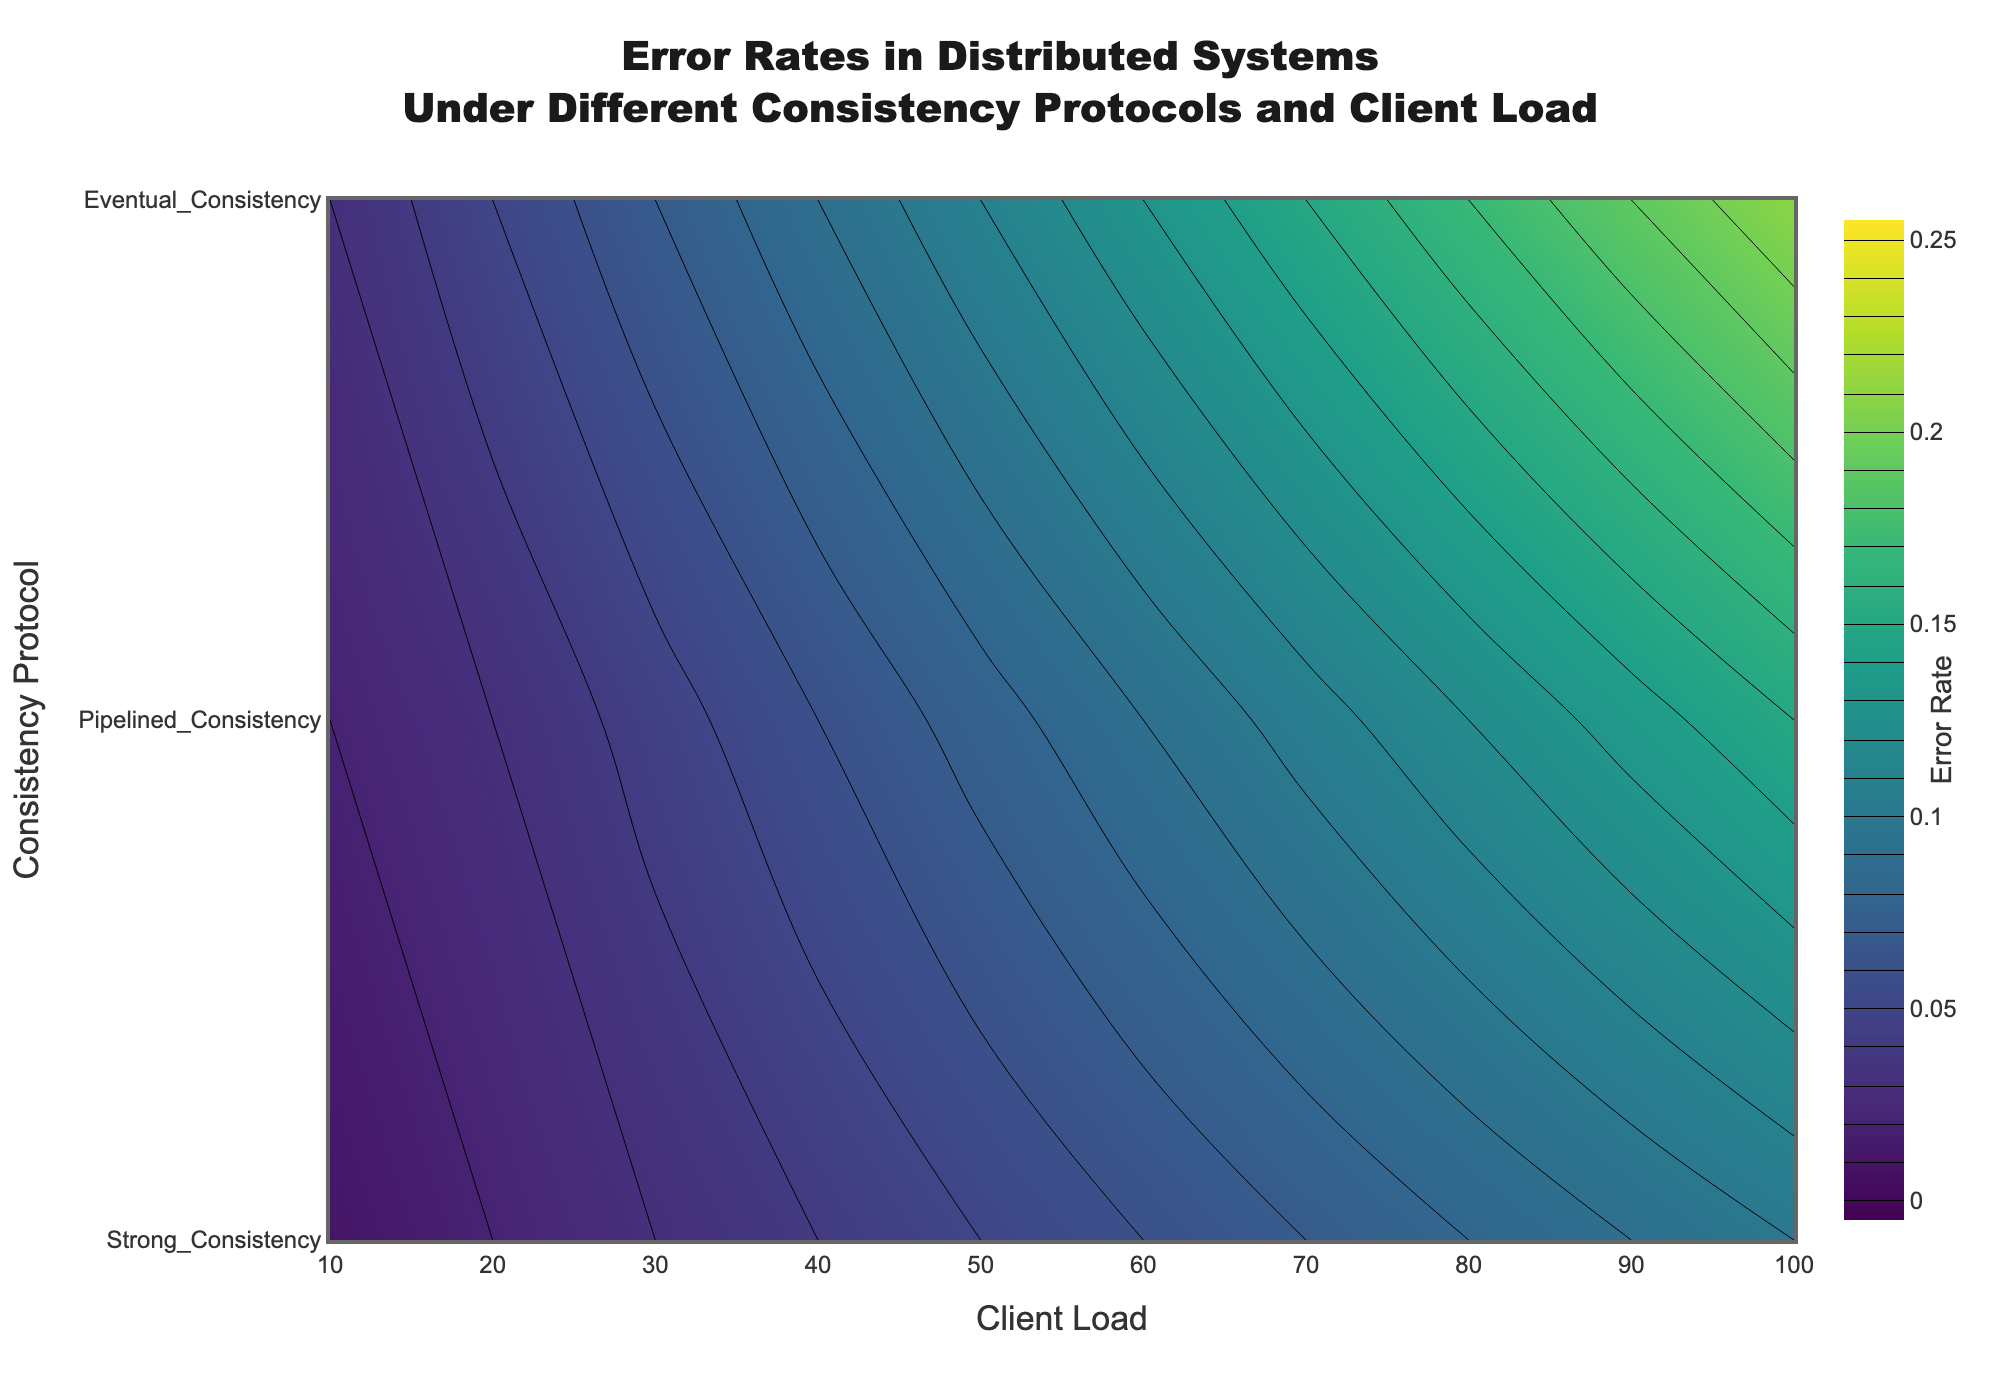What is the title of the contour plot? The title is located at the top center of the contour plot. It reads "Error Rates in Distributed Systems Under Different Consistency Protocols and Client Load."
Answer: Error Rates in Distributed Systems Under Different Consistency Protocols and Client Load What do the x and y axes represent? The x-axis represents "Client Load," and the y-axis represents "Consistency Protocol." These labels can be clearly seen near the axes in the plot.
Answer: Client Load (x), Consistency Protocol (y) What is the color indicating in the contour plot? The color in the contour plot represents the error rate, which can be inferred from the color scale bar labeled "Error Rate" on the right side of the plot.
Answer: Error rate At what client load does the Strong Consistency protocol reach an error rate of 0.05? Reference the Strong Consistency protocol on the y-axis and locate where the contour line intersects an error rate of 0.05. Then, check the corresponding client load on the x-axis.
Answer: 50 How does the error rate for Eventual Consistency change as the client load increases from 10 to 100? Follow the line for Eventual Consistency on the y-axis and observe how the color changes as it moves from left (client load 10) to right (client load 100). The error rate color scale can suggest a steady increase.
Answer: Increases steadily Which consistency protocol has the lowest error rate at a client load of 70? Locate the point on the x-axis corresponding to a client load of 70 and observe the colors for the three protocols at this load. The protocol with the lightest color indicates the lowest error rate.
Answer: Strong Consistency Between client loads 20 and 40, which protocol shows the fastest increase in error rate? Compare the color transitions for each protocol between client loads 20 and 40. The protocol with the steepest color gradient (changing from lighter to darker more quickly) indicates the fastest increase.
Answer: Pipelined Consistency At what range of client loads do all three protocols converge to an equal error rate? Identify where the lines for Strong Consistency, Pipelined Consistency, and Eventual Consistency intersect each other and share the same color in the color scale, suggesting an equal error rate.
Answer: They never converge to an equal error rate within the given range What is the error rate for Pipelined Consistency at a client load of 90? Locate the point on the x-axis corresponding to a client load of 90 and observe the color for Pipelined Consistency. Use the color scale to approximate the error rate.
Answer: 0.135 